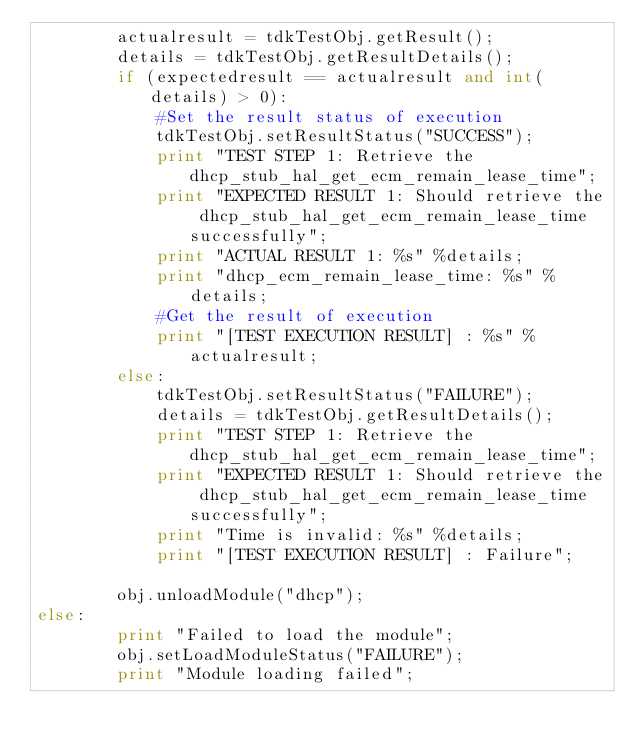Convert code to text. <code><loc_0><loc_0><loc_500><loc_500><_Python_>        actualresult = tdkTestObj.getResult();
        details = tdkTestObj.getResultDetails();
        if (expectedresult == actualresult and int(details) > 0):
            #Set the result status of execution
            tdkTestObj.setResultStatus("SUCCESS");
            print "TEST STEP 1: Retrieve the dhcp_stub_hal_get_ecm_remain_lease_time";
            print "EXPECTED RESULT 1: Should retrieve the dhcp_stub_hal_get_ecm_remain_lease_time successfully";
            print "ACTUAL RESULT 1: %s" %details;
            print "dhcp_ecm_remain_lease_time: %s" %details;
            #Get the result of execution
            print "[TEST EXECUTION RESULT] : %s" %actualresult; 
        else:
            tdkTestObj.setResultStatus("FAILURE");
            details = tdkTestObj.getResultDetails();
            print "TEST STEP 1: Retrieve the dhcp_stub_hal_get_ecm_remain_lease_time";
            print "EXPECTED RESULT 1: Should retrieve the dhcp_stub_hal_get_ecm_remain_lease_time successfully";
            print "Time is invalid: %s" %details;
            print "[TEST EXECUTION RESULT] : Failure";

        obj.unloadModule("dhcp");
else:
        print "Failed to load the module";
        obj.setLoadModuleStatus("FAILURE");
        print "Module loading failed";
</code> 